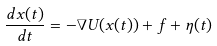Convert formula to latex. <formula><loc_0><loc_0><loc_500><loc_500>\frac { d x ( t ) } { d t } = - \nabla U ( x ( t ) ) + f + \eta ( t )</formula> 